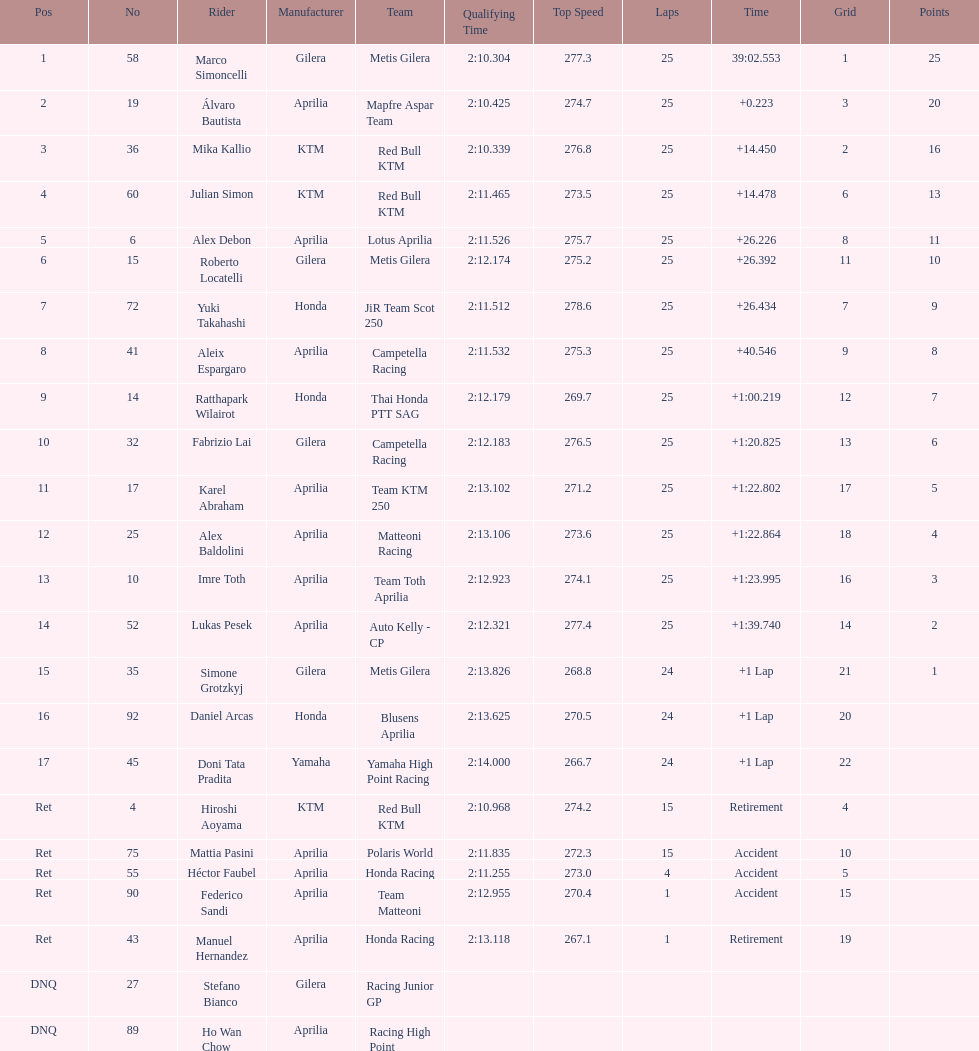The total amount of riders who did not qualify 2. 